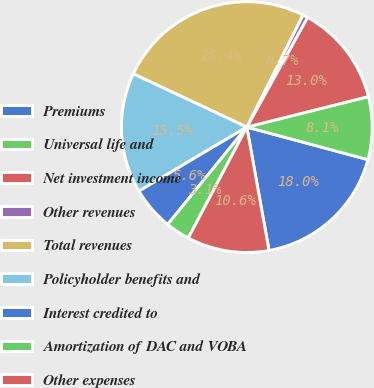<chart> <loc_0><loc_0><loc_500><loc_500><pie_chart><fcel>Premiums<fcel>Universal life and<fcel>Net investment income<fcel>Other revenues<fcel>Total revenues<fcel>Policyholder benefits and<fcel>Interest credited to<fcel>Amortization of DAC and VOBA<fcel>Other expenses<nl><fcel>17.99%<fcel>8.09%<fcel>13.04%<fcel>0.66%<fcel>25.41%<fcel>15.51%<fcel>5.61%<fcel>3.14%<fcel>10.56%<nl></chart> 